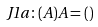Convert formula to latex. <formula><loc_0><loc_0><loc_500><loc_500>J 1 a \colon ( A ) A = ( )</formula> 